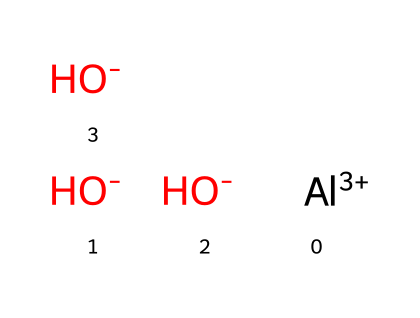How many hydroxide ions are present in this chemical? The SMILES representation shows three hydroxide ions, indicated by "[OH-]" which represents OH groups. Count the instances of "[OH-]" to find the quantity.
Answer: three What is the oxidation state of aluminum in this compound? In the SMILES, aluminum is represented with "[Al+3]", which indicates it has a plus three oxidation state. This informs us of the charge on the aluminum atom.
Answer: plus three What is the total number of atoms in this chemical? To determine the total number of atoms, count all atoms in the SMILES. There are one aluminum atom (Al), three oxygen atoms (from three OH groups), and three hydrogen atoms (from three OH groups), leading to a total of seven atoms.
Answer: seven What role does aluminum hydroxide play in vaccines? Aluminum hydroxide serves as an adjuvant, which is a substance that enhances the body's immune response to an antigen, making vaccines more effective. This is based on its known biological function.
Answer: adjuvant How can this chemical structure affect immune response? The presence of aluminum hydroxide increases the local immune response at the injection site by attracting immune cells and enhancing antigen presentation, thus intensifying the effectiveness of the vaccine. This involves understanding the mechanism by which adjuvants work.
Answer: enhances immune response Is this compound soluble in water? Aluminum hydroxide is poorly soluble in water, which means that it does not dissolve readily, impacting how it functions as an adjuvant in a vaccine formulation. Recognizing the solubility of this compound is essential for its application in vaccines.
Answer: poorly soluble 